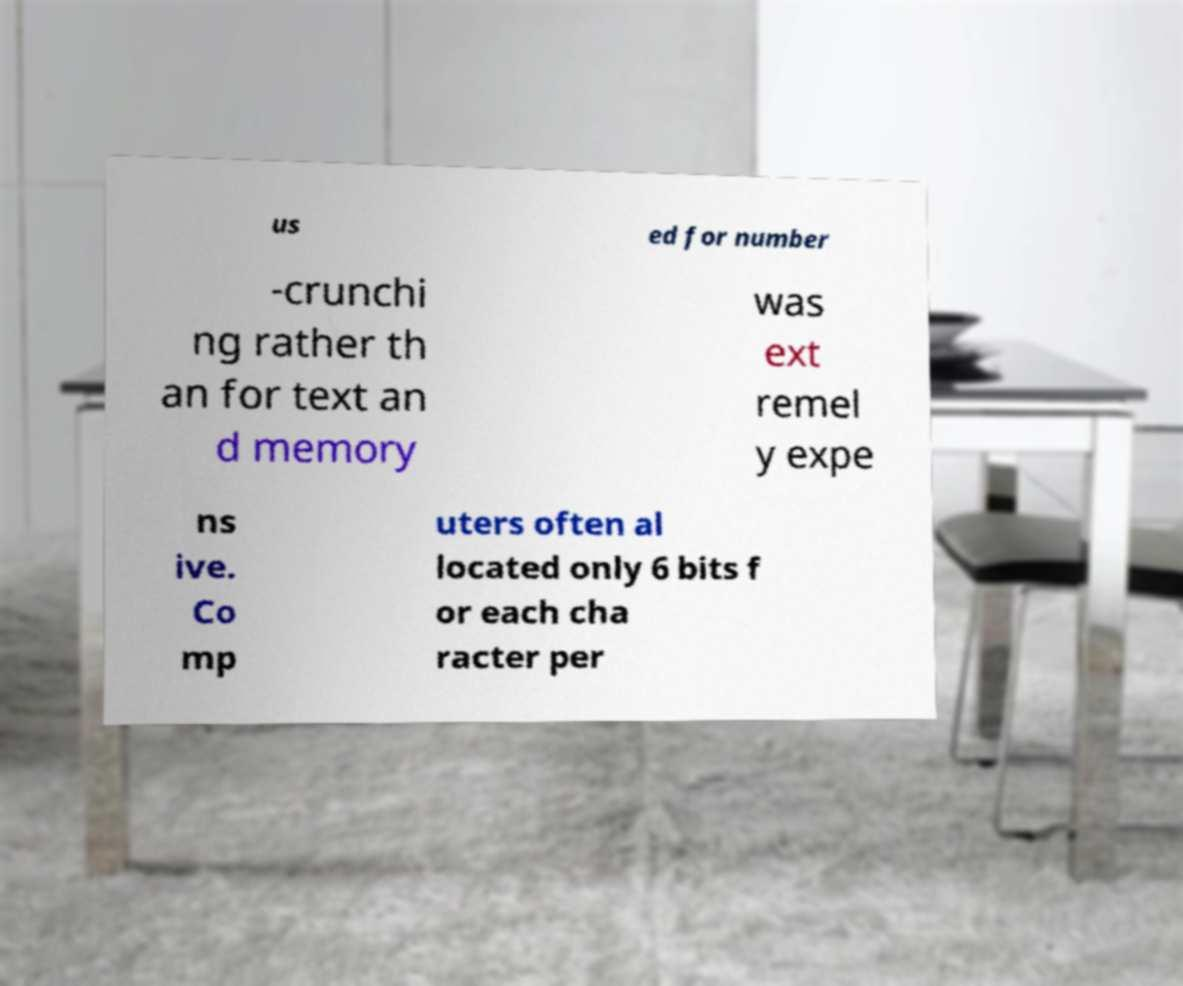Please identify and transcribe the text found in this image. us ed for number -crunchi ng rather th an for text an d memory was ext remel y expe ns ive. Co mp uters often al located only 6 bits f or each cha racter per 